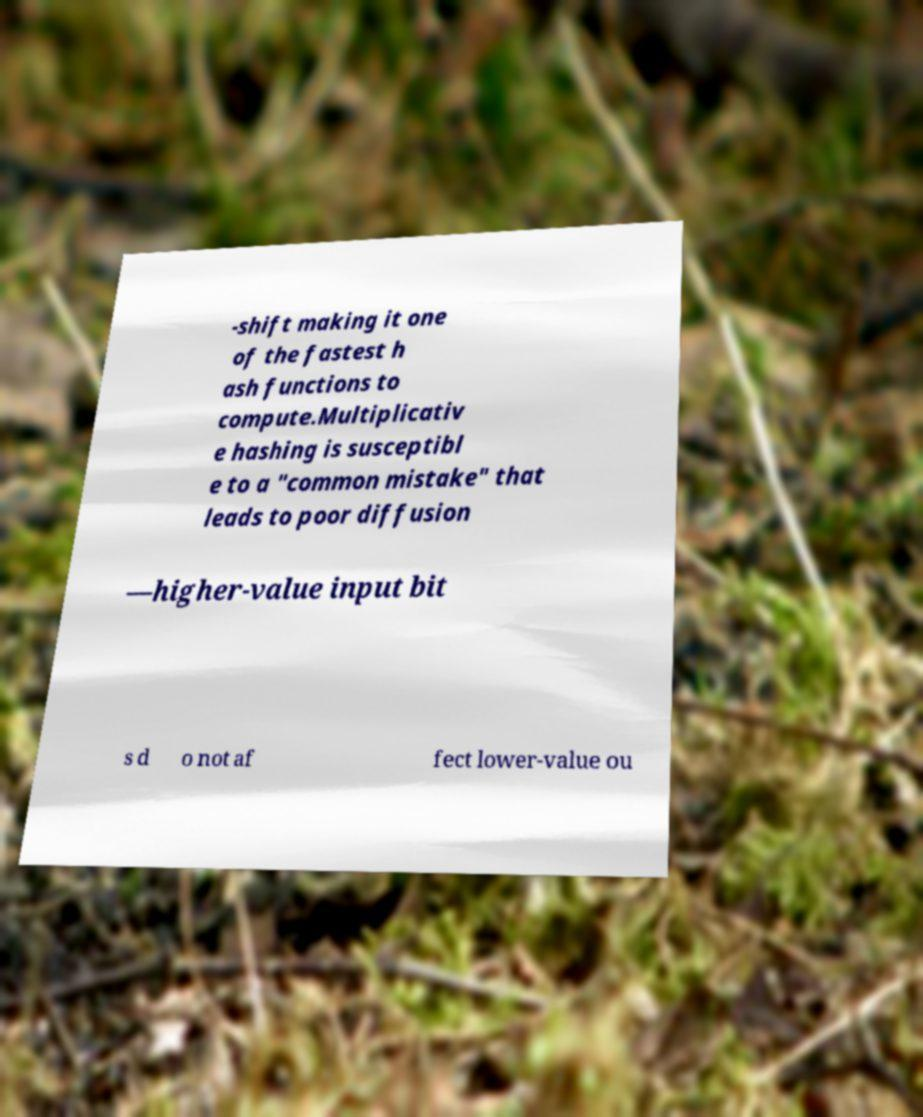I need the written content from this picture converted into text. Can you do that? -shift making it one of the fastest h ash functions to compute.Multiplicativ e hashing is susceptibl e to a "common mistake" that leads to poor diffusion —higher-value input bit s d o not af fect lower-value ou 